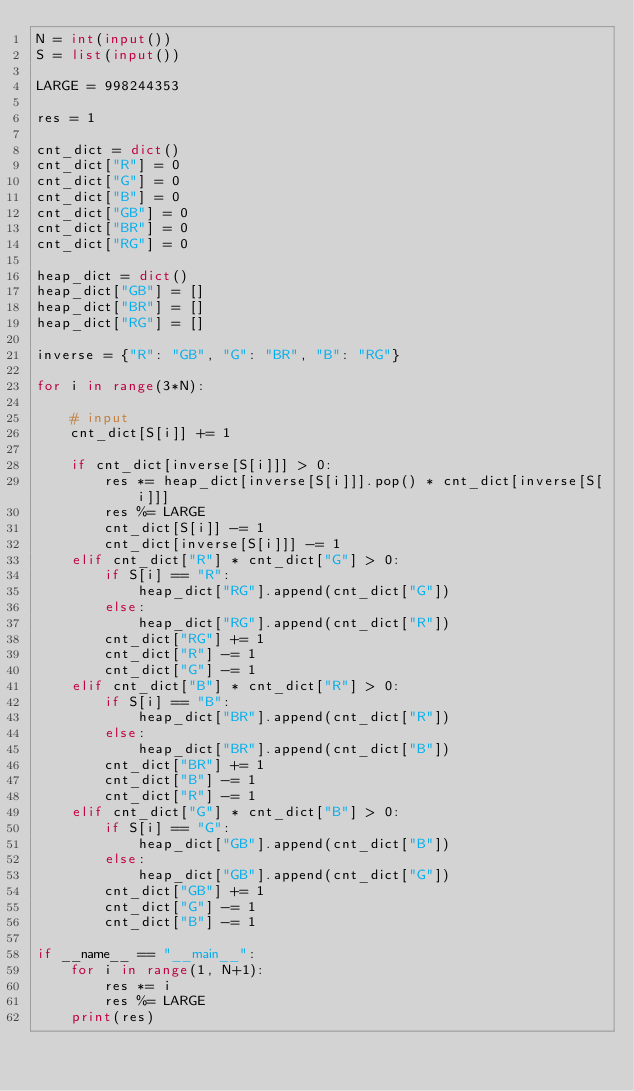<code> <loc_0><loc_0><loc_500><loc_500><_Python_>N = int(input())
S = list(input())

LARGE = 998244353

res = 1

cnt_dict = dict()
cnt_dict["R"] = 0
cnt_dict["G"] = 0
cnt_dict["B"] = 0
cnt_dict["GB"] = 0
cnt_dict["BR"] = 0
cnt_dict["RG"] = 0

heap_dict = dict()
heap_dict["GB"] = []
heap_dict["BR"] = []
heap_dict["RG"] = []

inverse = {"R": "GB", "G": "BR", "B": "RG"}

for i in range(3*N):

    # input
    cnt_dict[S[i]] += 1

    if cnt_dict[inverse[S[i]]] > 0:
        res *= heap_dict[inverse[S[i]]].pop() * cnt_dict[inverse[S[i]]]
        res %= LARGE
        cnt_dict[S[i]] -= 1
        cnt_dict[inverse[S[i]]] -= 1
    elif cnt_dict["R"] * cnt_dict["G"] > 0:
        if S[i] == "R":
            heap_dict["RG"].append(cnt_dict["G"])
        else:
            heap_dict["RG"].append(cnt_dict["R"])
        cnt_dict["RG"] += 1
        cnt_dict["R"] -= 1
        cnt_dict["G"] -= 1
    elif cnt_dict["B"] * cnt_dict["R"] > 0:
        if S[i] == "B":
            heap_dict["BR"].append(cnt_dict["R"])
        else:
            heap_dict["BR"].append(cnt_dict["B"])
        cnt_dict["BR"] += 1
        cnt_dict["B"] -= 1
        cnt_dict["R"] -= 1
    elif cnt_dict["G"] * cnt_dict["B"] > 0:
        if S[i] == "G":
            heap_dict["GB"].append(cnt_dict["B"])
        else:
            heap_dict["GB"].append(cnt_dict["G"])
        cnt_dict["GB"] += 1
        cnt_dict["G"] -= 1
        cnt_dict["B"] -= 1

if __name__ == "__main__":
    for i in range(1, N+1):
        res *= i
        res %= LARGE
    print(res)
</code> 